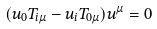Convert formula to latex. <formula><loc_0><loc_0><loc_500><loc_500>( u _ { 0 } T _ { i \mu } - u _ { i } T _ { 0 \mu } ) u ^ { \mu } = 0</formula> 